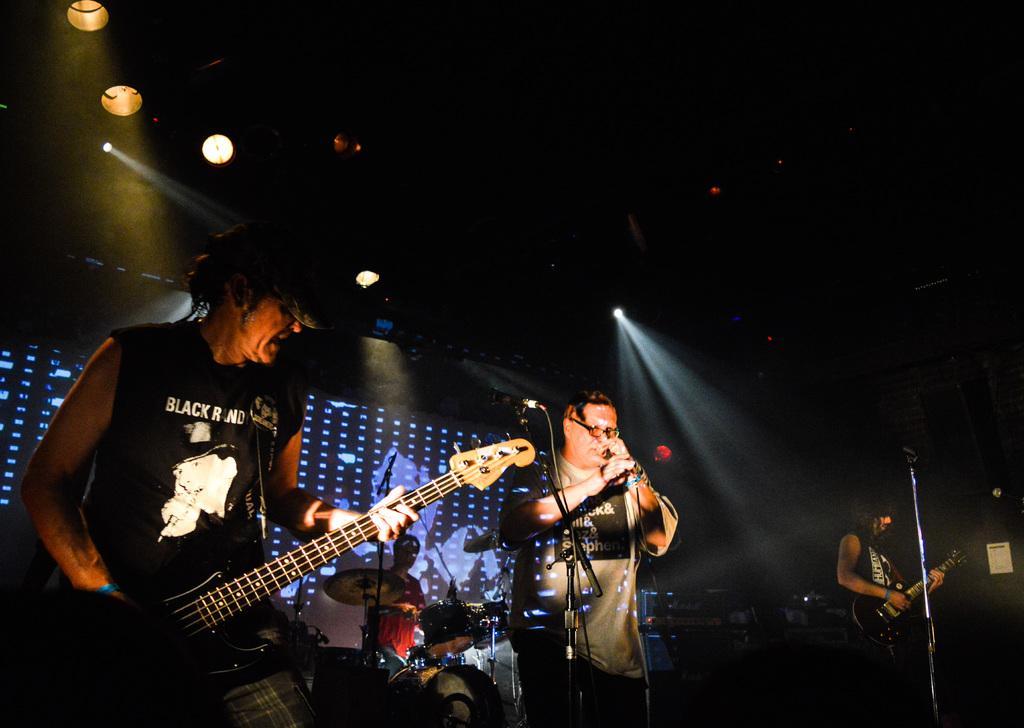Please provide a concise description of this image. In this picture we can see four people, mics, musical instruments, lights and some objects and two people holding guitars with their hands and in the background it is dark. 